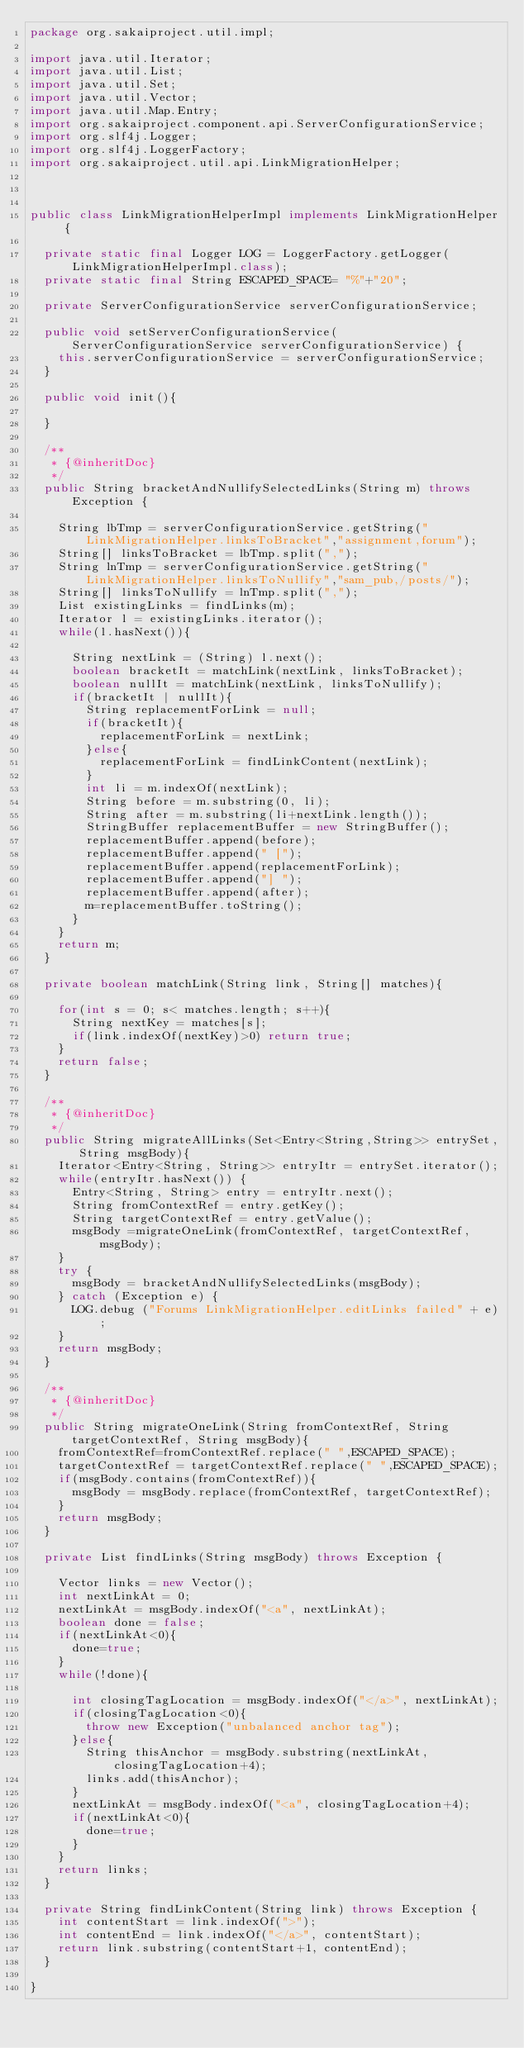<code> <loc_0><loc_0><loc_500><loc_500><_Java_>package org.sakaiproject.util.impl;

import java.util.Iterator;
import java.util.List;
import java.util.Set;
import java.util.Vector;
import java.util.Map.Entry;
import org.sakaiproject.component.api.ServerConfigurationService;
import org.slf4j.Logger;
import org.slf4j.LoggerFactory;
import org.sakaiproject.util.api.LinkMigrationHelper;



public class LinkMigrationHelperImpl implements LinkMigrationHelper {

	private static final Logger LOG = LoggerFactory.getLogger(LinkMigrationHelperImpl.class);
	private static final String ESCAPED_SPACE= "%"+"20";

	private ServerConfigurationService serverConfigurationService;

	public void setServerConfigurationService(ServerConfigurationService serverConfigurationService) {
		this.serverConfigurationService = serverConfigurationService;
	}

	public void init(){
		
	}

	/**
	 * {@inheritDoc}
	 */
	public String bracketAndNullifySelectedLinks(String m) throws Exception {
		
		String lbTmp = serverConfigurationService.getString("LinkMigrationHelper.linksToBracket","assignment,forum");
		String[] linksToBracket = lbTmp.split(",");
		String lnTmp = serverConfigurationService.getString("LinkMigrationHelper.linksToNullify","sam_pub,/posts/");
		String[] linksToNullify = lnTmp.split(",");
		List existingLinks = findLinks(m);
		Iterator l = existingLinks.iterator();
		while(l.hasNext()){
			
			String nextLink = (String) l.next();
			boolean bracketIt = matchLink(nextLink, linksToBracket);
			boolean nullIt = matchLink(nextLink, linksToNullify);
			if(bracketIt | nullIt){
				String replacementForLink = null;
				if(bracketIt){
					replacementForLink = nextLink;
				}else{
					replacementForLink = findLinkContent(nextLink);
				}
				int li = m.indexOf(nextLink);
				String before = m.substring(0, li);
				String after = m.substring(li+nextLink.length());
				StringBuffer replacementBuffer = new StringBuffer();
				replacementBuffer.append(before);
				replacementBuffer.append(" [");
				replacementBuffer.append(replacementForLink);
				replacementBuffer.append("] ");
				replacementBuffer.append(after);
				m=replacementBuffer.toString();
			}
		}
		return m;
	}

	private boolean matchLink(String link, String[] matches){
		
		for(int s = 0; s< matches.length; s++){
			String nextKey = matches[s];
			if(link.indexOf(nextKey)>0) return true;
		}
		return false;
	}

	/**
	 * {@inheritDoc}
	 */
	public String migrateAllLinks(Set<Entry<String,String>> entrySet, String msgBody){
		Iterator<Entry<String, String>> entryItr = entrySet.iterator();
		while(entryItr.hasNext()) {
			Entry<String, String> entry = entryItr.next();
			String fromContextRef = entry.getKey();
			String targetContextRef = entry.getValue();
			msgBody =migrateOneLink(fromContextRef, targetContextRef, msgBody);
		}
		try {
			msgBody = bracketAndNullifySelectedLinks(msgBody);
		} catch (Exception e) {
			LOG.debug ("Forums LinkMigrationHelper.editLinks failed" + e);
		}
		return msgBody;
	}

	/**
	 * {@inheritDoc}
	 */
	public String migrateOneLink(String fromContextRef, String targetContextRef, String msgBody){
		fromContextRef=fromContextRef.replace(" ",ESCAPED_SPACE);
		targetContextRef = targetContextRef.replace(" ",ESCAPED_SPACE);
		if(msgBody.contains(fromContextRef)){
			msgBody = msgBody.replace(fromContextRef, targetContextRef);
		}
		return msgBody;
	}

	private List findLinks(String msgBody) throws Exception {
		
		Vector links = new Vector();
		int nextLinkAt = 0;
		nextLinkAt = msgBody.indexOf("<a", nextLinkAt);
		boolean done = false;
		if(nextLinkAt<0){
			done=true;
		}
		while(!done){
			
			int closingTagLocation = msgBody.indexOf("</a>", nextLinkAt);
			if(closingTagLocation<0){
				throw new Exception("unbalanced anchor tag");
			}else{
				String thisAnchor = msgBody.substring(nextLinkAt, closingTagLocation+4);
				links.add(thisAnchor);
			}
			nextLinkAt = msgBody.indexOf("<a", closingTagLocation+4);
			if(nextLinkAt<0){
				done=true;
			}
		}
		return links;
	}
	
	private String findLinkContent(String link) throws Exception {
		int contentStart = link.indexOf(">");
		int contentEnd = link.indexOf("</a>", contentStart);
		return link.substring(contentStart+1, contentEnd);
	}

}
</code> 